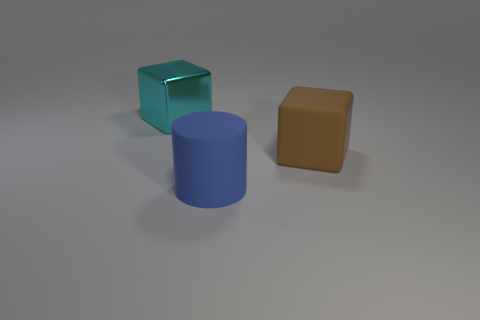Are there any other things that have the same material as the cyan object?
Ensure brevity in your answer.  No. How many other objects are the same size as the brown rubber cube?
Provide a short and direct response. 2. There is a cube that is behind the big brown block; what material is it?
Provide a succinct answer. Metal. There is a large object that is to the left of the large matte thing left of the big cube on the right side of the shiny thing; what shape is it?
Offer a terse response. Cube. What number of objects are either small green metallic objects or blocks to the right of the metal cube?
Provide a short and direct response. 1. What number of things are big things to the right of the metal object or blocks in front of the cyan metal thing?
Make the answer very short. 2. There is a cyan thing; are there any metal cubes in front of it?
Offer a very short reply. No. There is a object that is behind the block in front of the large object behind the large brown block; what color is it?
Give a very brief answer. Cyan. Is the cyan thing the same shape as the brown thing?
Your response must be concise. Yes. What is the color of the other big thing that is made of the same material as the blue object?
Your response must be concise. Brown. 